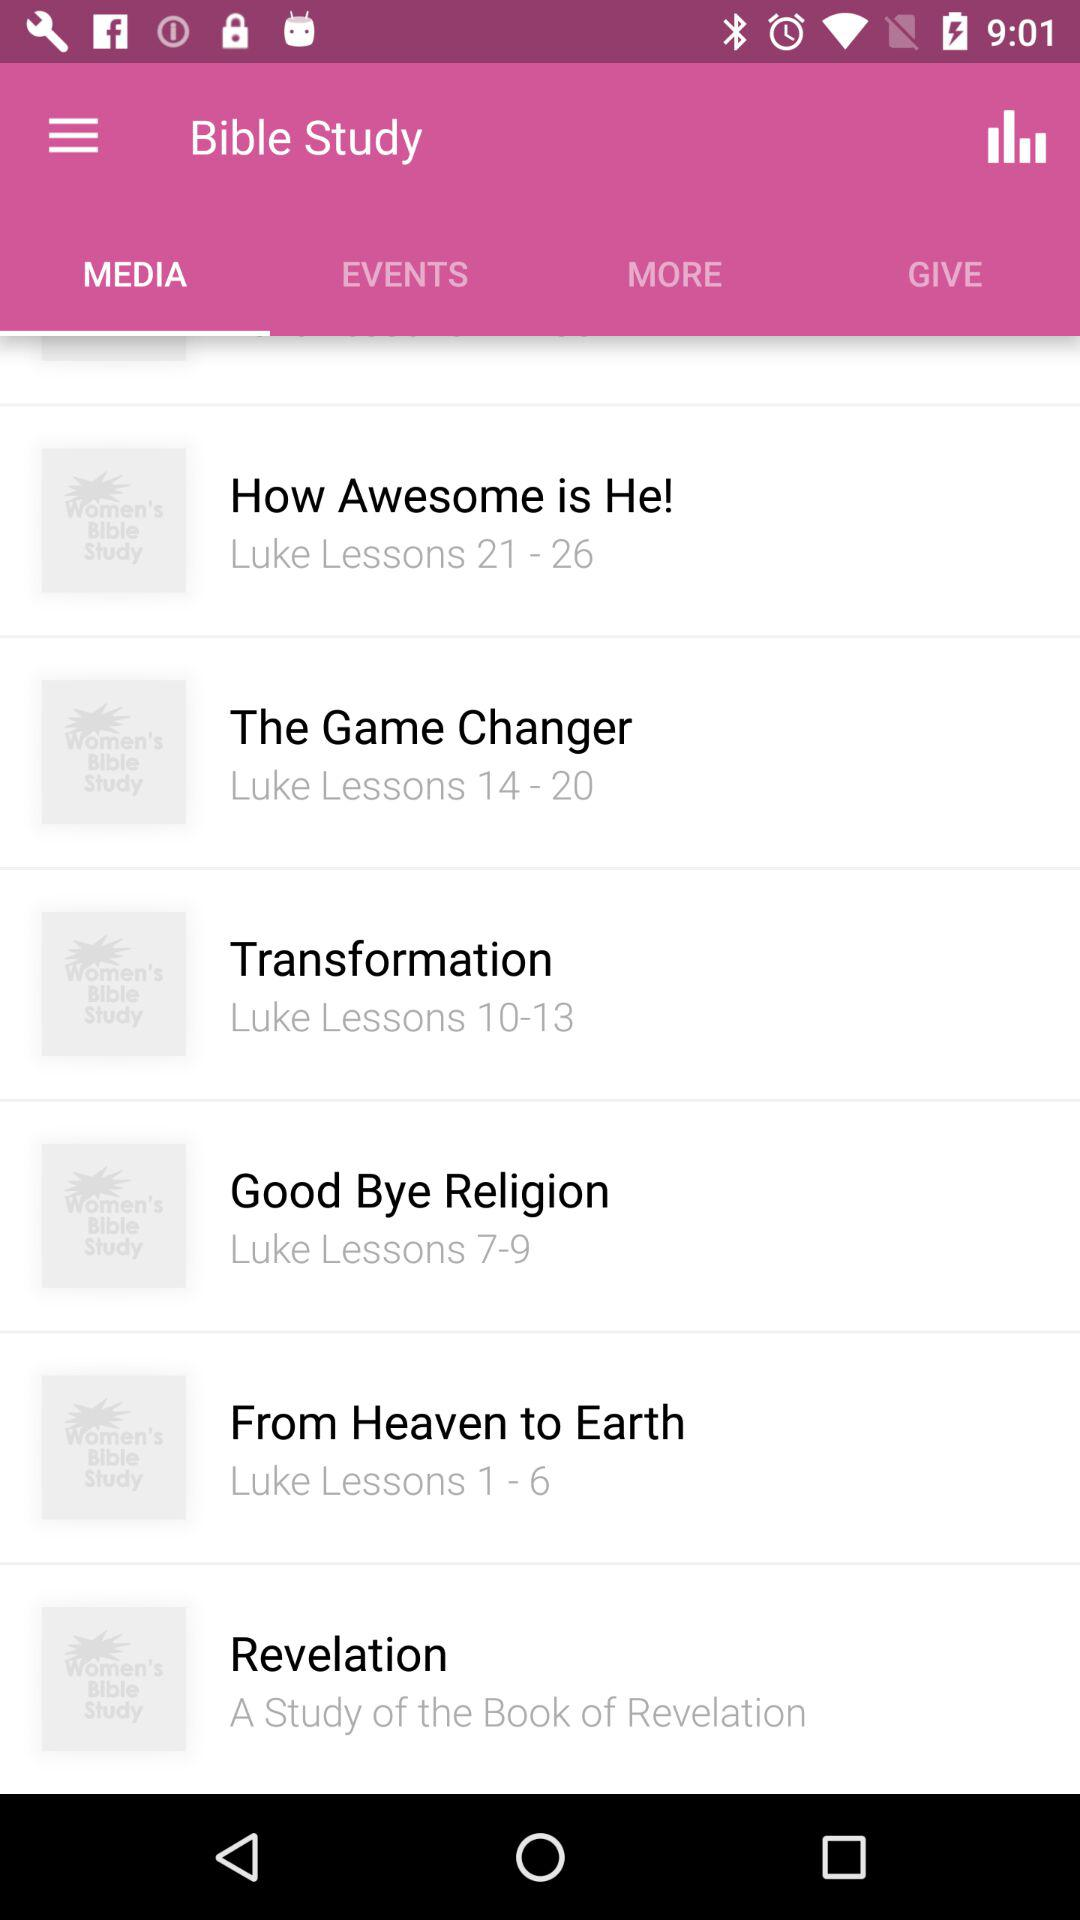Which lessons are included in "Good Bye Religion"? The lessons that are included in "Good Bye Religion" are "Luke Lessons 7-9". 